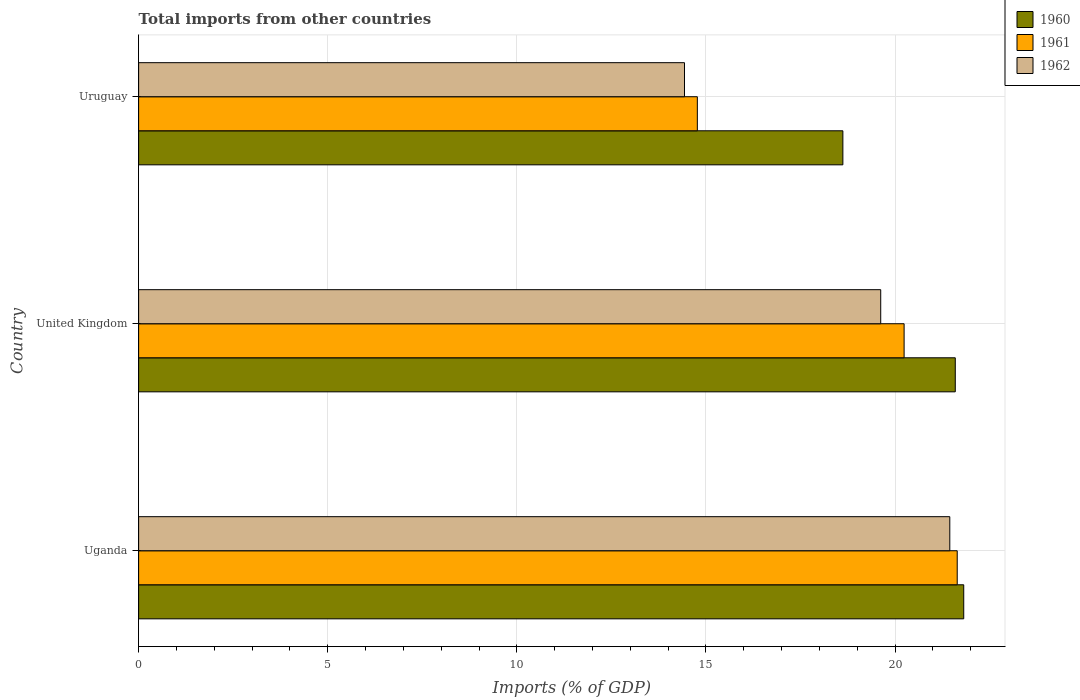How many bars are there on the 3rd tick from the bottom?
Your answer should be compact. 3. What is the label of the 3rd group of bars from the top?
Your response must be concise. Uganda. In how many cases, is the number of bars for a given country not equal to the number of legend labels?
Provide a succinct answer. 0. What is the total imports in 1961 in United Kingdom?
Give a very brief answer. 20.24. Across all countries, what is the maximum total imports in 1962?
Offer a terse response. 21.45. Across all countries, what is the minimum total imports in 1960?
Keep it short and to the point. 18.62. In which country was the total imports in 1960 maximum?
Make the answer very short. Uganda. In which country was the total imports in 1960 minimum?
Your answer should be compact. Uruguay. What is the total total imports in 1960 in the graph?
Your answer should be compact. 62.03. What is the difference between the total imports in 1962 in Uganda and that in Uruguay?
Keep it short and to the point. 7.01. What is the difference between the total imports in 1960 in Uganda and the total imports in 1961 in United Kingdom?
Keep it short and to the point. 1.58. What is the average total imports in 1962 per country?
Ensure brevity in your answer.  18.5. What is the difference between the total imports in 1960 and total imports in 1961 in Uruguay?
Provide a short and direct response. 3.85. In how many countries, is the total imports in 1961 greater than 6 %?
Offer a terse response. 3. What is the ratio of the total imports in 1960 in Uganda to that in Uruguay?
Your response must be concise. 1.17. What is the difference between the highest and the second highest total imports in 1960?
Your answer should be compact. 0.22. What is the difference between the highest and the lowest total imports in 1960?
Your answer should be very brief. 3.2. In how many countries, is the total imports in 1961 greater than the average total imports in 1961 taken over all countries?
Keep it short and to the point. 2. Is the sum of the total imports in 1962 in Uganda and Uruguay greater than the maximum total imports in 1960 across all countries?
Provide a short and direct response. Yes. What does the 1st bar from the top in Uganda represents?
Your answer should be very brief. 1962. How many bars are there?
Give a very brief answer. 9. What is the difference between two consecutive major ticks on the X-axis?
Ensure brevity in your answer.  5. Does the graph contain any zero values?
Provide a short and direct response. No. Does the graph contain grids?
Provide a short and direct response. Yes. Where does the legend appear in the graph?
Offer a terse response. Top right. What is the title of the graph?
Your answer should be compact. Total imports from other countries. Does "1983" appear as one of the legend labels in the graph?
Provide a succinct answer. No. What is the label or title of the X-axis?
Provide a short and direct response. Imports (% of GDP). What is the Imports (% of GDP) of 1960 in Uganda?
Provide a succinct answer. 21.82. What is the Imports (% of GDP) in 1961 in Uganda?
Provide a succinct answer. 21.64. What is the Imports (% of GDP) of 1962 in Uganda?
Your answer should be very brief. 21.45. What is the Imports (% of GDP) in 1960 in United Kingdom?
Provide a succinct answer. 21.59. What is the Imports (% of GDP) of 1961 in United Kingdom?
Ensure brevity in your answer.  20.24. What is the Imports (% of GDP) in 1962 in United Kingdom?
Provide a short and direct response. 19.62. What is the Imports (% of GDP) of 1960 in Uruguay?
Provide a short and direct response. 18.62. What is the Imports (% of GDP) in 1961 in Uruguay?
Ensure brevity in your answer.  14.77. What is the Imports (% of GDP) of 1962 in Uruguay?
Your answer should be compact. 14.43. Across all countries, what is the maximum Imports (% of GDP) of 1960?
Ensure brevity in your answer.  21.82. Across all countries, what is the maximum Imports (% of GDP) in 1961?
Your response must be concise. 21.64. Across all countries, what is the maximum Imports (% of GDP) in 1962?
Provide a succinct answer. 21.45. Across all countries, what is the minimum Imports (% of GDP) of 1960?
Provide a succinct answer. 18.62. Across all countries, what is the minimum Imports (% of GDP) of 1961?
Offer a very short reply. 14.77. Across all countries, what is the minimum Imports (% of GDP) of 1962?
Give a very brief answer. 14.43. What is the total Imports (% of GDP) of 1960 in the graph?
Your answer should be compact. 62.03. What is the total Imports (% of GDP) in 1961 in the graph?
Keep it short and to the point. 56.66. What is the total Imports (% of GDP) in 1962 in the graph?
Offer a terse response. 55.5. What is the difference between the Imports (% of GDP) of 1960 in Uganda and that in United Kingdom?
Make the answer very short. 0.22. What is the difference between the Imports (% of GDP) in 1961 in Uganda and that in United Kingdom?
Give a very brief answer. 1.4. What is the difference between the Imports (% of GDP) of 1962 in Uganda and that in United Kingdom?
Give a very brief answer. 1.83. What is the difference between the Imports (% of GDP) of 1960 in Uganda and that in Uruguay?
Give a very brief answer. 3.2. What is the difference between the Imports (% of GDP) of 1961 in Uganda and that in Uruguay?
Make the answer very short. 6.87. What is the difference between the Imports (% of GDP) of 1962 in Uganda and that in Uruguay?
Keep it short and to the point. 7.01. What is the difference between the Imports (% of GDP) of 1960 in United Kingdom and that in Uruguay?
Make the answer very short. 2.97. What is the difference between the Imports (% of GDP) of 1961 in United Kingdom and that in Uruguay?
Your response must be concise. 5.47. What is the difference between the Imports (% of GDP) of 1962 in United Kingdom and that in Uruguay?
Provide a succinct answer. 5.19. What is the difference between the Imports (% of GDP) in 1960 in Uganda and the Imports (% of GDP) in 1961 in United Kingdom?
Your answer should be compact. 1.58. What is the difference between the Imports (% of GDP) in 1960 in Uganda and the Imports (% of GDP) in 1962 in United Kingdom?
Offer a terse response. 2.2. What is the difference between the Imports (% of GDP) in 1961 in Uganda and the Imports (% of GDP) in 1962 in United Kingdom?
Ensure brevity in your answer.  2.02. What is the difference between the Imports (% of GDP) in 1960 in Uganda and the Imports (% of GDP) in 1961 in Uruguay?
Your answer should be very brief. 7.04. What is the difference between the Imports (% of GDP) in 1960 in Uganda and the Imports (% of GDP) in 1962 in Uruguay?
Your answer should be compact. 7.38. What is the difference between the Imports (% of GDP) of 1961 in Uganda and the Imports (% of GDP) of 1962 in Uruguay?
Offer a terse response. 7.21. What is the difference between the Imports (% of GDP) in 1960 in United Kingdom and the Imports (% of GDP) in 1961 in Uruguay?
Provide a succinct answer. 6.82. What is the difference between the Imports (% of GDP) of 1960 in United Kingdom and the Imports (% of GDP) of 1962 in Uruguay?
Keep it short and to the point. 7.16. What is the difference between the Imports (% of GDP) of 1961 in United Kingdom and the Imports (% of GDP) of 1962 in Uruguay?
Give a very brief answer. 5.81. What is the average Imports (% of GDP) of 1960 per country?
Keep it short and to the point. 20.68. What is the average Imports (% of GDP) in 1961 per country?
Keep it short and to the point. 18.89. What is the average Imports (% of GDP) in 1962 per country?
Make the answer very short. 18.5. What is the difference between the Imports (% of GDP) of 1960 and Imports (% of GDP) of 1961 in Uganda?
Your response must be concise. 0.17. What is the difference between the Imports (% of GDP) in 1960 and Imports (% of GDP) in 1962 in Uganda?
Ensure brevity in your answer.  0.37. What is the difference between the Imports (% of GDP) of 1961 and Imports (% of GDP) of 1962 in Uganda?
Give a very brief answer. 0.2. What is the difference between the Imports (% of GDP) of 1960 and Imports (% of GDP) of 1961 in United Kingdom?
Your answer should be very brief. 1.35. What is the difference between the Imports (% of GDP) of 1960 and Imports (% of GDP) of 1962 in United Kingdom?
Provide a succinct answer. 1.97. What is the difference between the Imports (% of GDP) of 1961 and Imports (% of GDP) of 1962 in United Kingdom?
Provide a short and direct response. 0.62. What is the difference between the Imports (% of GDP) of 1960 and Imports (% of GDP) of 1961 in Uruguay?
Your answer should be compact. 3.85. What is the difference between the Imports (% of GDP) in 1960 and Imports (% of GDP) in 1962 in Uruguay?
Offer a very short reply. 4.19. What is the difference between the Imports (% of GDP) of 1961 and Imports (% of GDP) of 1962 in Uruguay?
Offer a very short reply. 0.34. What is the ratio of the Imports (% of GDP) in 1960 in Uganda to that in United Kingdom?
Your answer should be very brief. 1.01. What is the ratio of the Imports (% of GDP) of 1961 in Uganda to that in United Kingdom?
Make the answer very short. 1.07. What is the ratio of the Imports (% of GDP) in 1962 in Uganda to that in United Kingdom?
Ensure brevity in your answer.  1.09. What is the ratio of the Imports (% of GDP) in 1960 in Uganda to that in Uruguay?
Keep it short and to the point. 1.17. What is the ratio of the Imports (% of GDP) of 1961 in Uganda to that in Uruguay?
Offer a terse response. 1.47. What is the ratio of the Imports (% of GDP) of 1962 in Uganda to that in Uruguay?
Your answer should be very brief. 1.49. What is the ratio of the Imports (% of GDP) of 1960 in United Kingdom to that in Uruguay?
Give a very brief answer. 1.16. What is the ratio of the Imports (% of GDP) in 1961 in United Kingdom to that in Uruguay?
Your response must be concise. 1.37. What is the ratio of the Imports (% of GDP) in 1962 in United Kingdom to that in Uruguay?
Your answer should be very brief. 1.36. What is the difference between the highest and the second highest Imports (% of GDP) of 1960?
Provide a short and direct response. 0.22. What is the difference between the highest and the second highest Imports (% of GDP) in 1961?
Your answer should be compact. 1.4. What is the difference between the highest and the second highest Imports (% of GDP) in 1962?
Ensure brevity in your answer.  1.83. What is the difference between the highest and the lowest Imports (% of GDP) of 1960?
Your response must be concise. 3.2. What is the difference between the highest and the lowest Imports (% of GDP) of 1961?
Ensure brevity in your answer.  6.87. What is the difference between the highest and the lowest Imports (% of GDP) of 1962?
Provide a short and direct response. 7.01. 